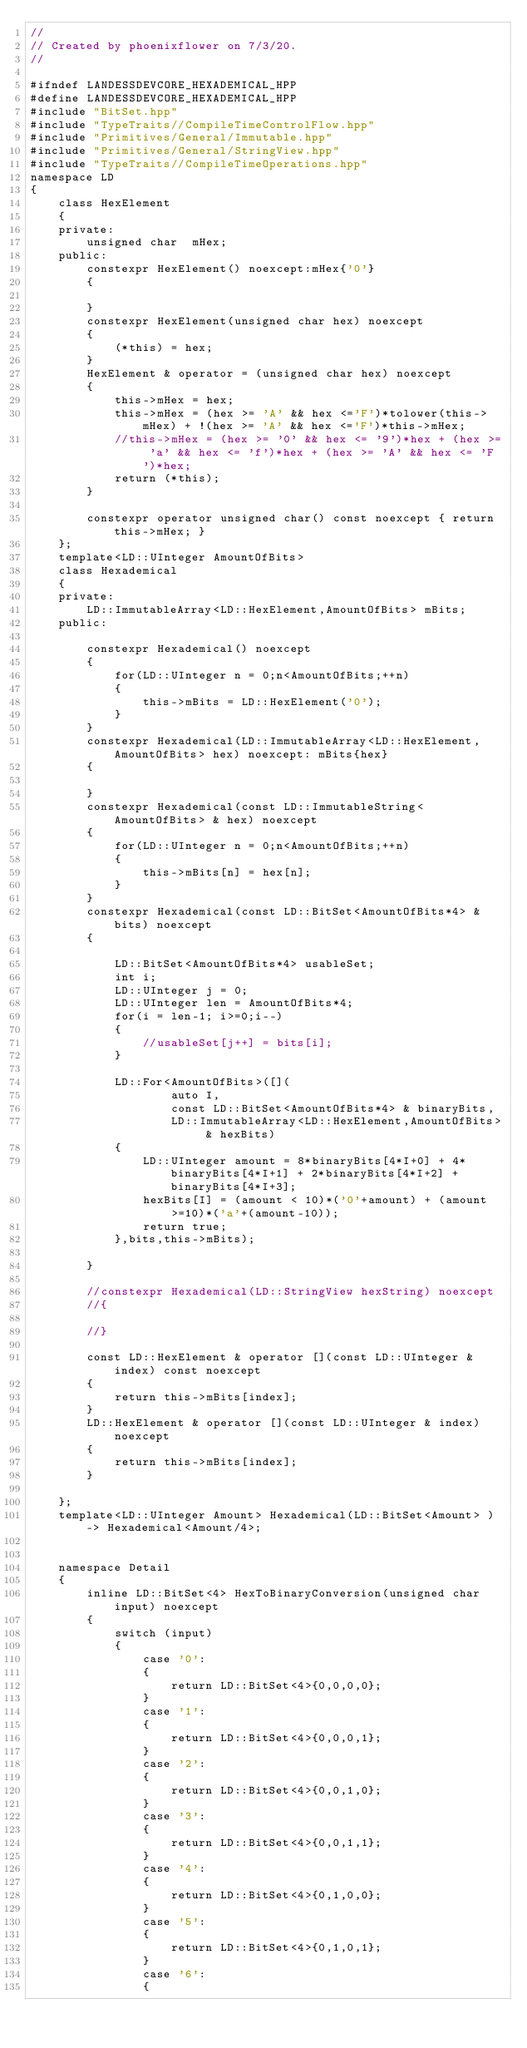<code> <loc_0><loc_0><loc_500><loc_500><_C++_>//
// Created by phoenixflower on 7/3/20.
//

#ifndef LANDESSDEVCORE_HEXADEMICAL_HPP
#define LANDESSDEVCORE_HEXADEMICAL_HPP
#include "BitSet.hpp"
#include "TypeTraits//CompileTimeControlFlow.hpp"
#include "Primitives/General/Immutable.hpp"
#include "Primitives/General/StringView.hpp"
#include "TypeTraits//CompileTimeOperations.hpp"
namespace LD
{
    class HexElement
    {
    private:
        unsigned char  mHex;
    public:
        constexpr HexElement() noexcept:mHex{'0'}
        {

        }
        constexpr HexElement(unsigned char hex) noexcept
        {
            (*this) = hex;
        }
        HexElement & operator = (unsigned char hex) noexcept
        {
            this->mHex = hex;
            this->mHex = (hex >= 'A' && hex <='F')*tolower(this->mHex) + !(hex >= 'A' && hex <='F')*this->mHex;
            //this->mHex = (hex >= '0' && hex <= '9')*hex + (hex >= 'a' && hex <= 'f')*hex + (hex >= 'A' && hex <= 'F')*hex;
            return (*this);
        }

        constexpr operator unsigned char() const noexcept { return this->mHex; }
    };
    template<LD::UInteger AmountOfBits>
    class Hexademical
    {
    private:
        LD::ImmutableArray<LD::HexElement,AmountOfBits> mBits;
    public:

        constexpr Hexademical() noexcept
        {
            for(LD::UInteger n = 0;n<AmountOfBits;++n)
            {
                this->mBits = LD::HexElement('0');
            }
        }
        constexpr Hexademical(LD::ImmutableArray<LD::HexElement,AmountOfBits> hex) noexcept: mBits{hex}
        {

        }
        constexpr Hexademical(const LD::ImmutableString<AmountOfBits> & hex) noexcept
        {
            for(LD::UInteger n = 0;n<AmountOfBits;++n)
            {
                this->mBits[n] = hex[n];
            }
        }
        constexpr Hexademical(const LD::BitSet<AmountOfBits*4> & bits) noexcept
        {

            LD::BitSet<AmountOfBits*4> usableSet;
            int i;
            LD::UInteger j = 0;
            LD::UInteger len = AmountOfBits*4;
            for(i = len-1; i>=0;i--)
            {
                //usableSet[j++] = bits[i];
            }

            LD::For<AmountOfBits>([](
                    auto I,
                    const LD::BitSet<AmountOfBits*4> & binaryBits,
                    LD::ImmutableArray<LD::HexElement,AmountOfBits> & hexBits)
            {
                LD::UInteger amount = 8*binaryBits[4*I+0] + 4*binaryBits[4*I+1] + 2*binaryBits[4*I+2] + binaryBits[4*I+3];
                hexBits[I] = (amount < 10)*('0'+amount) + (amount >=10)*('a'+(amount-10));
                return true;
            },bits,this->mBits);

        }

        //constexpr Hexademical(LD::StringView hexString) noexcept
        //{

        //}

        const LD::HexElement & operator [](const LD::UInteger & index) const noexcept
        {
            return this->mBits[index];
        }
        LD::HexElement & operator [](const LD::UInteger & index) noexcept
        {
            return this->mBits[index];
        }

    };
    template<LD::UInteger Amount> Hexademical(LD::BitSet<Amount> ) -> Hexademical<Amount/4>;


    namespace Detail
    {
        inline LD::BitSet<4> HexToBinaryConversion(unsigned char input) noexcept
        {
            switch (input)
            {
                case '0':
                {
                    return LD::BitSet<4>{0,0,0,0};
                }
                case '1':
                {
                    return LD::BitSet<4>{0,0,0,1};
                }
                case '2':
                {
                    return LD::BitSet<4>{0,0,1,0};
                }
                case '3':
                {
                    return LD::BitSet<4>{0,0,1,1};
                }
                case '4':
                {
                    return LD::BitSet<4>{0,1,0,0};
                }
                case '5':
                {
                    return LD::BitSet<4>{0,1,0,1};
                }
                case '6':
                {</code> 